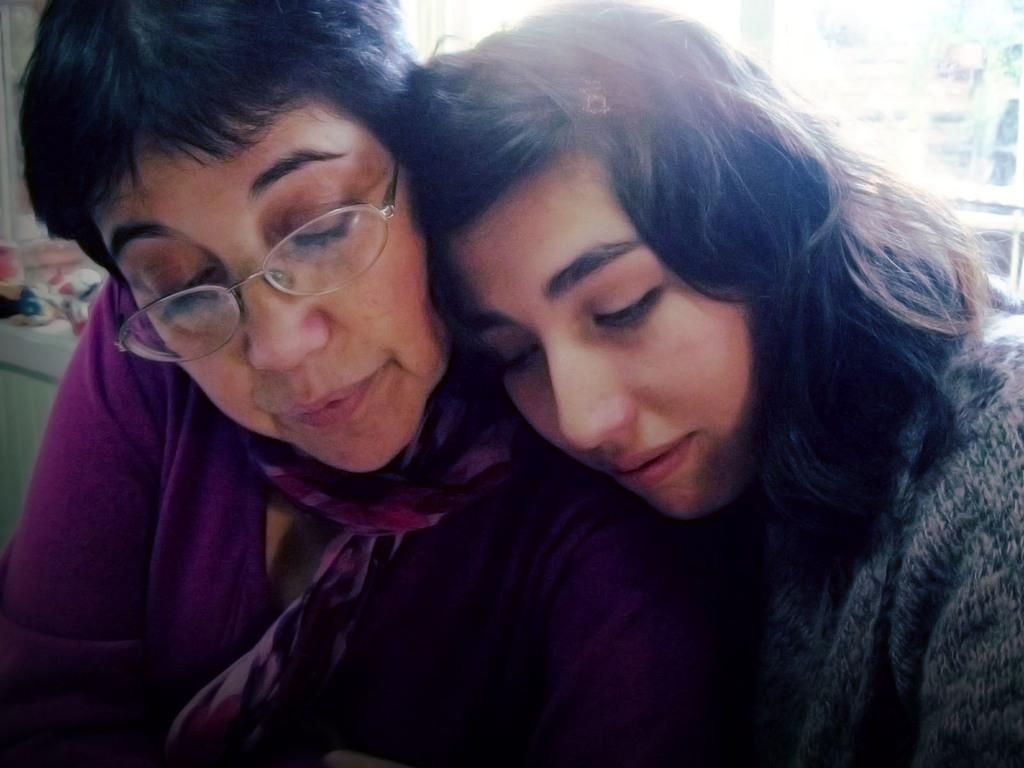How many people are in the image? There are two ladies in the image. What can be seen on a table in the image? There are objects on a table in the image. Can you describe the background of the image? The background of the image is blurred. Reasoning: Let'g: Let's think step by step in order to produce the conversation. We start by identifying the main subjects in the image, which are the two ladies. Then, we mention the presence of a table with objects on it, which is another important detail. Finally, we describe the background of the image, noting that it is blurred. Each question is designed to elicit a specific detail about the image that is known from the provided facts. Absurd Question/Answer: Are there any rabbits hopping in the garden visible in the image? There is no garden or rabbits present in the image. 